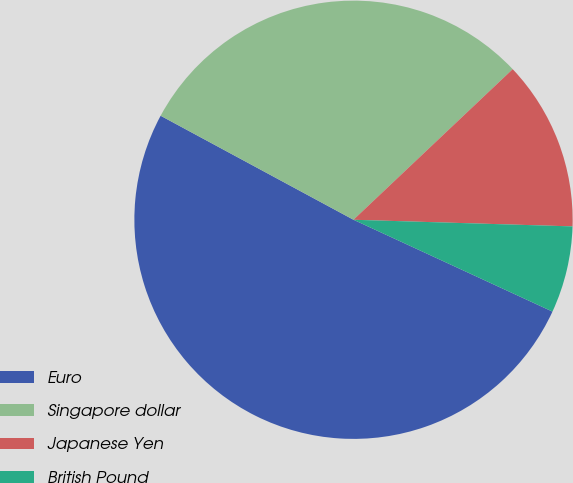<chart> <loc_0><loc_0><loc_500><loc_500><pie_chart><fcel>Euro<fcel>Singapore dollar<fcel>Japanese Yen<fcel>British Pound<nl><fcel>50.99%<fcel>30.07%<fcel>12.54%<fcel>6.4%<nl></chart> 